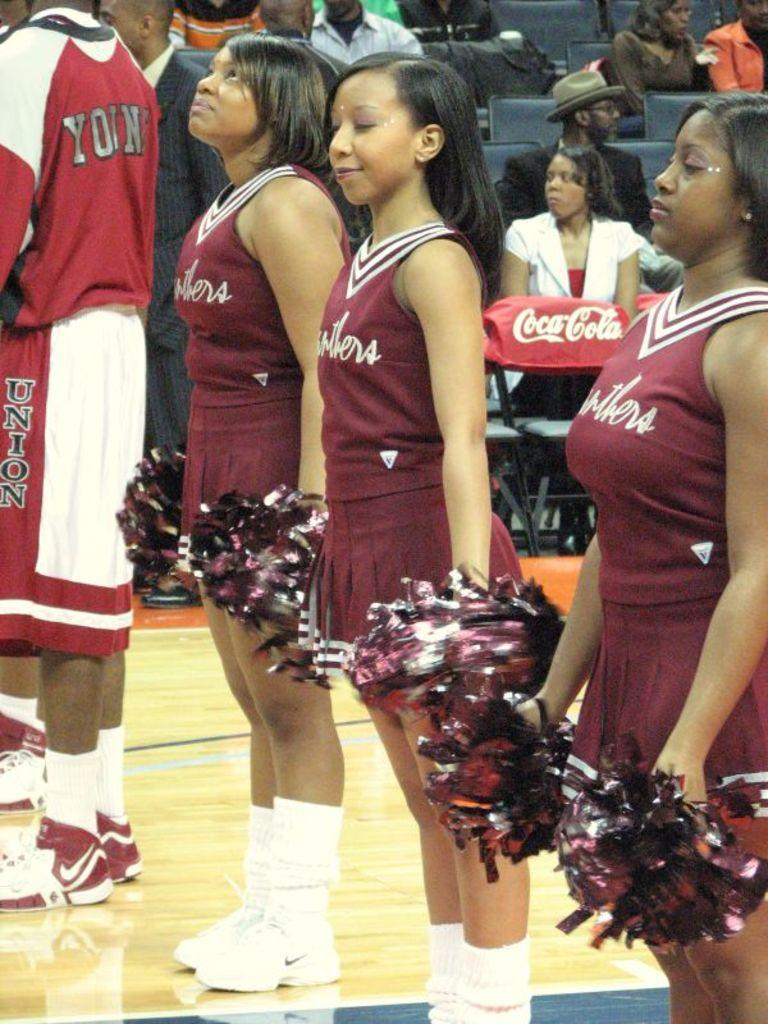<image>
Render a clear and concise summary of the photo. The ballplayer's shorts have the word union written down the side. 